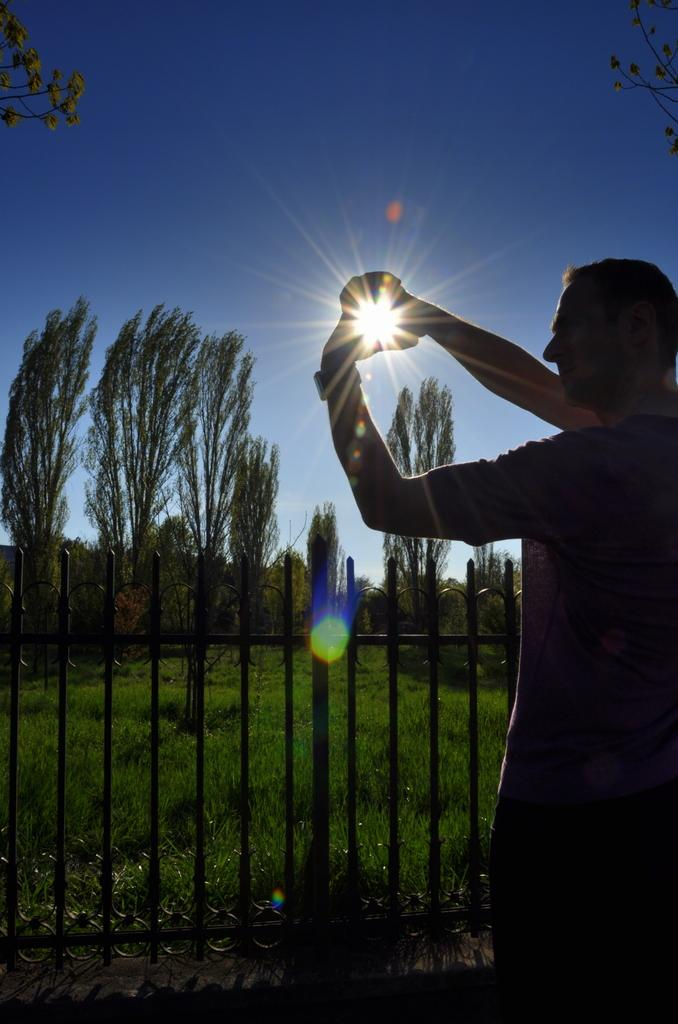What is the main subject in the foreground of the image? There is a man standing on the road in the foreground of the image. What is the man doing in the image? The man is giving a pose to the camera. What can be seen in the background of the image? There is railing, grass, trees, and the sky visible in the background of the image. Can the sun be seen in the sky? Yes, the sun is observable in the sky. What is the cause of death for the person lying on the grass in the image? There is no person lying on the grass in the image; it only shows a man standing on the road and the background elements. 